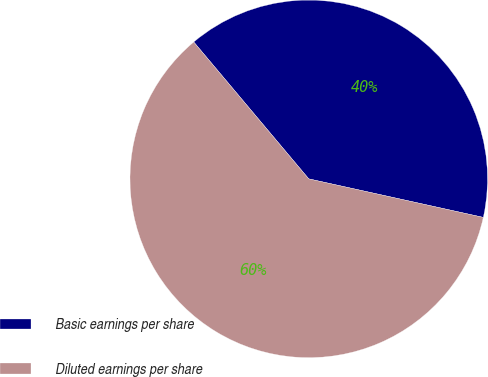Convert chart. <chart><loc_0><loc_0><loc_500><loc_500><pie_chart><fcel>Basic earnings per share<fcel>Diluted earnings per share<nl><fcel>39.58%<fcel>60.42%<nl></chart> 